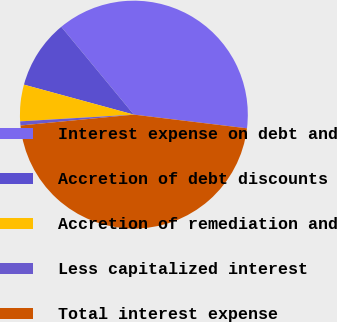Convert chart. <chart><loc_0><loc_0><loc_500><loc_500><pie_chart><fcel>Interest expense on debt and<fcel>Accretion of debt discounts<fcel>Accretion of remediation and<fcel>Less capitalized interest<fcel>Total interest expense<nl><fcel>37.91%<fcel>9.77%<fcel>5.18%<fcel>0.58%<fcel>46.56%<nl></chart> 